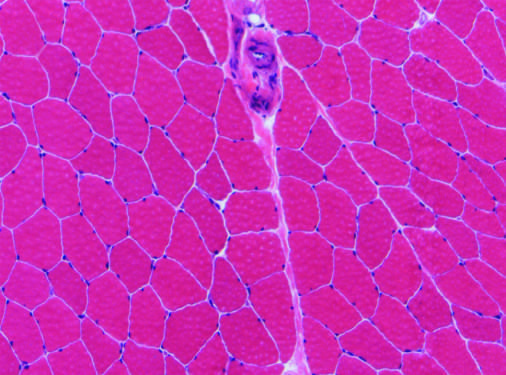what does normal skeletal muscle tissue have?
Answer the question using a single word or phrase. Relatively uniform polygonal myofibers with peripherally placed nuclei that are tightly packed together into fascicles separated by scant connective tissue 